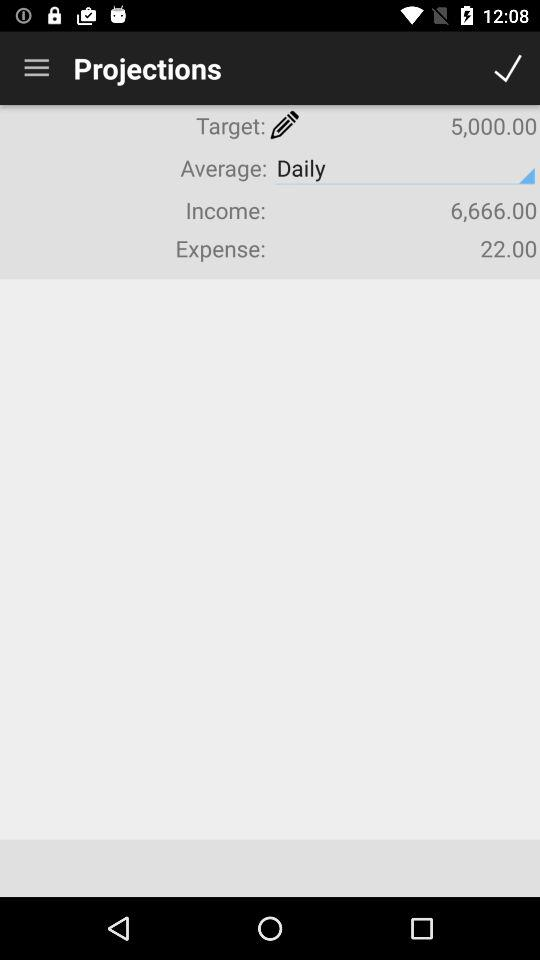What is the target? The target is "5,000.00". 